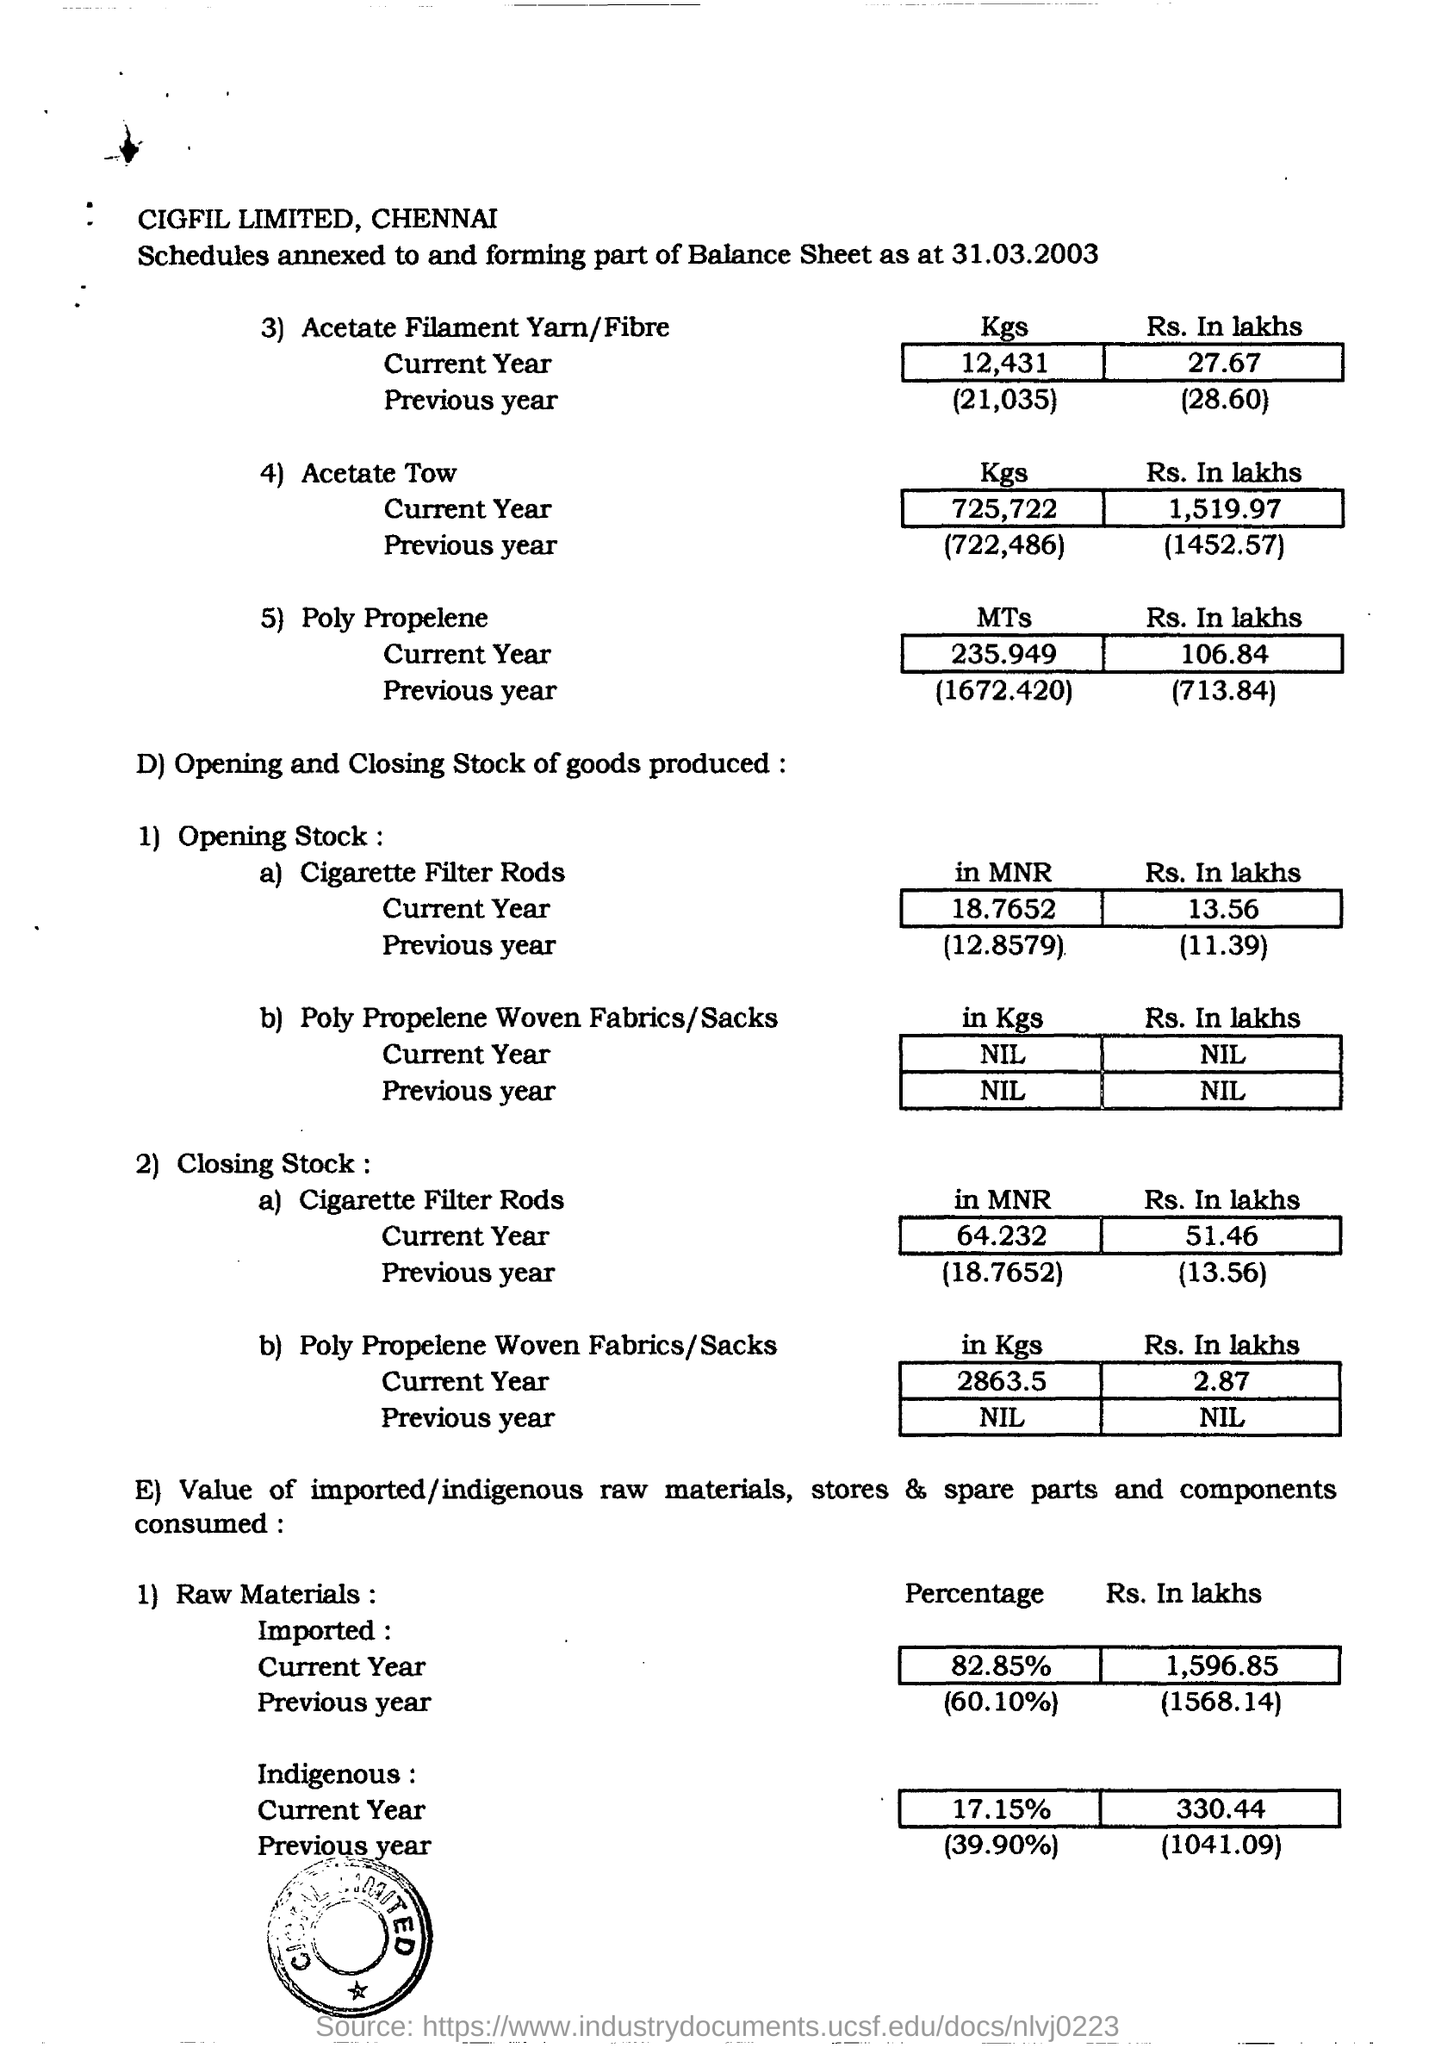Outline some significant characteristics in this image. In the current year, a significant percentage of raw materials (82.85%) were imported. In the previous year, approximately 60.10% of the raw materials used were imported. The date mentioned in the document is 31st March 2003. 